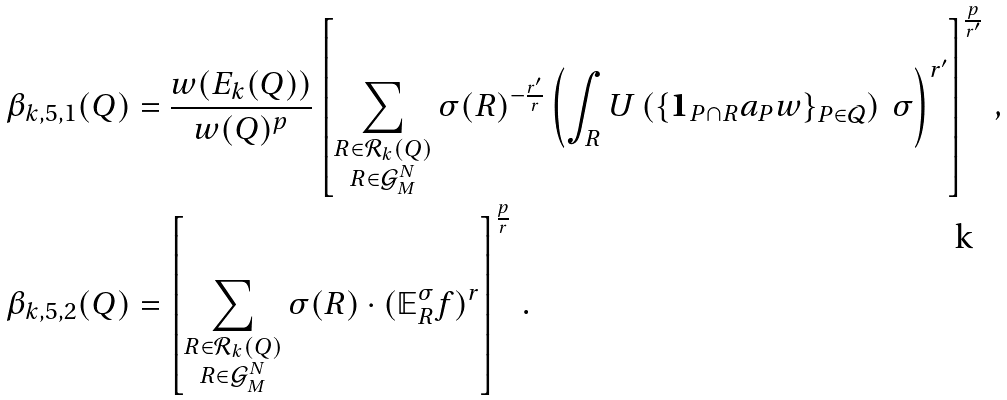Convert formula to latex. <formula><loc_0><loc_0><loc_500><loc_500>\beta _ { k , 5 , 1 } ( Q ) & = \frac { w ( E _ { k } ( Q ) ) } { w ( Q ) ^ { p } } \left [ \sum _ { \substack { { R \in \mathcal { R } _ { k } ( Q ) } \\ R \in \mathcal { G } ^ { N } _ { M } } } \sigma ( R ) ^ { - \frac { r ^ { \prime } } { r } } \left ( \int _ { R } U \left ( \{ \mathbf 1 _ { P \cap R } a _ { P } w \} _ { P \in \mathcal { Q } } \right ) \, \sigma \right ) ^ { r ^ { \prime } } \right ] ^ { \frac { p } { r ^ { \prime } } } \, , \\ \beta _ { k , 5 , 2 } ( Q ) & = \left [ \sum _ { \substack { { R \in \mathcal { R } _ { k } ( Q ) } \\ R \in \mathcal { G } ^ { N } _ { M } } } \sigma ( R ) \cdot ( \mathbb { E } _ { R } ^ { \sigma } f ) ^ { r } \right ] ^ { \frac { p } { r } } \, .</formula> 